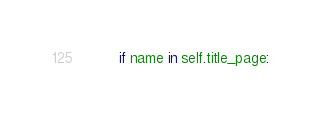Convert code to text. <code><loc_0><loc_0><loc_500><loc_500><_Python_>        if name in self.title_page:</code> 